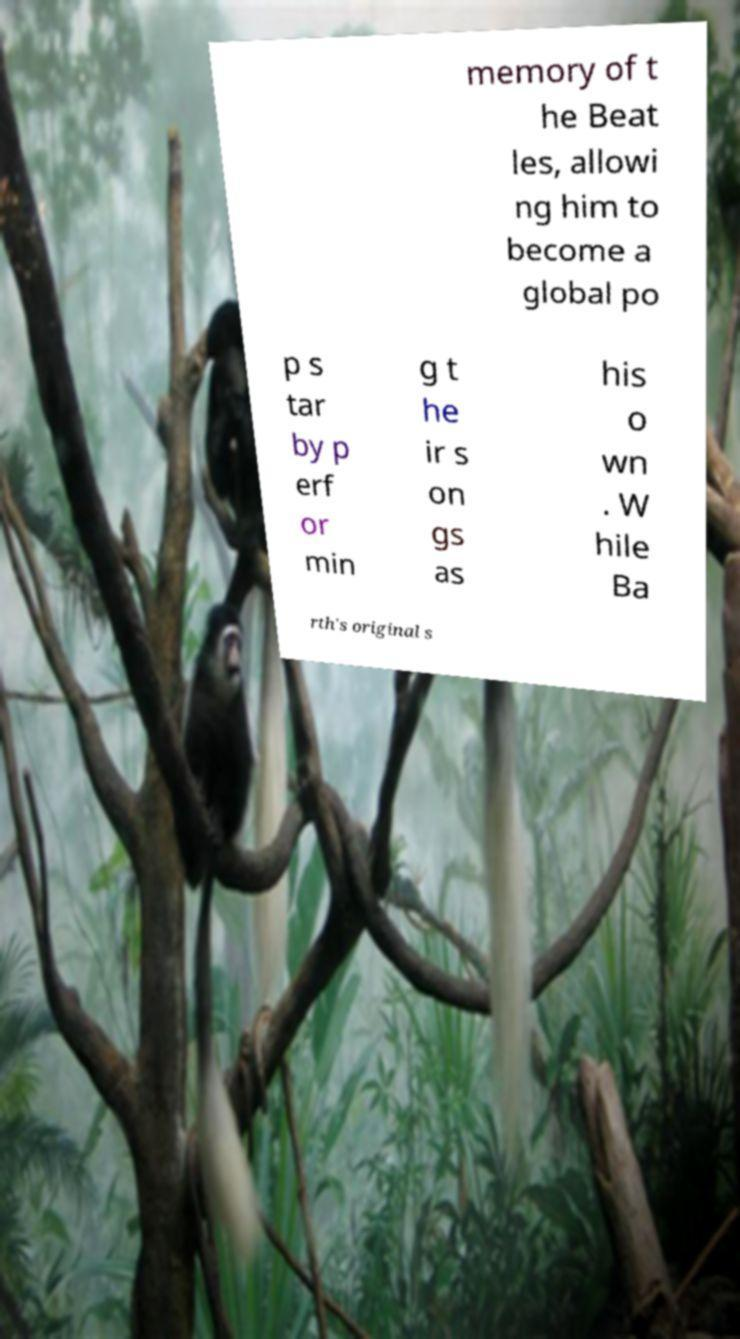Can you read and provide the text displayed in the image?This photo seems to have some interesting text. Can you extract and type it out for me? memory of t he Beat les, allowi ng him to become a global po p s tar by p erf or min g t he ir s on gs as his o wn . W hile Ba rth's original s 